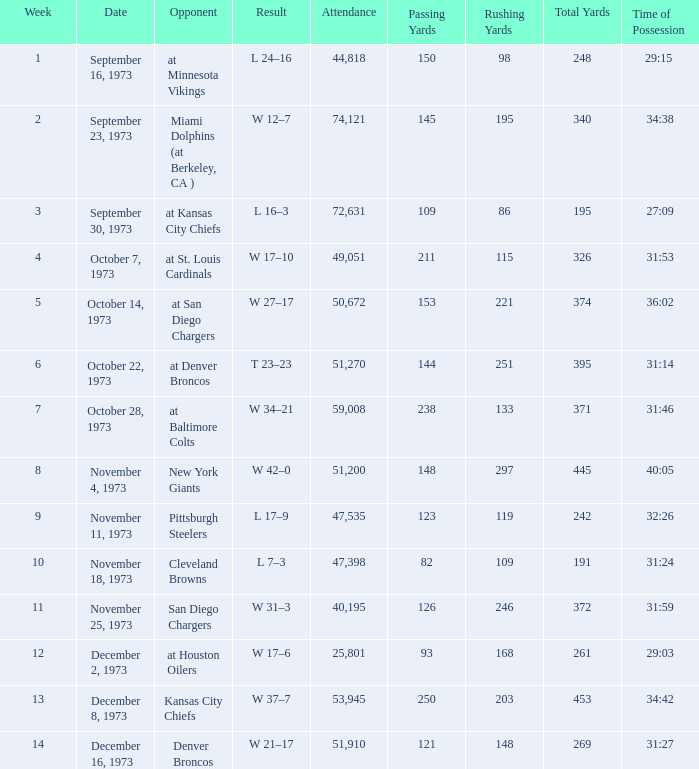What is the attendance for the game against the Kansas City Chiefs earlier than week 13? None. 